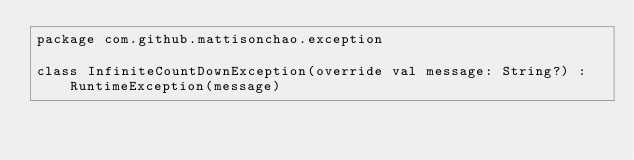<code> <loc_0><loc_0><loc_500><loc_500><_Kotlin_>package com.github.mattisonchao.exception

class InfiniteCountDownException(override val message: String?) : RuntimeException(message)
</code> 